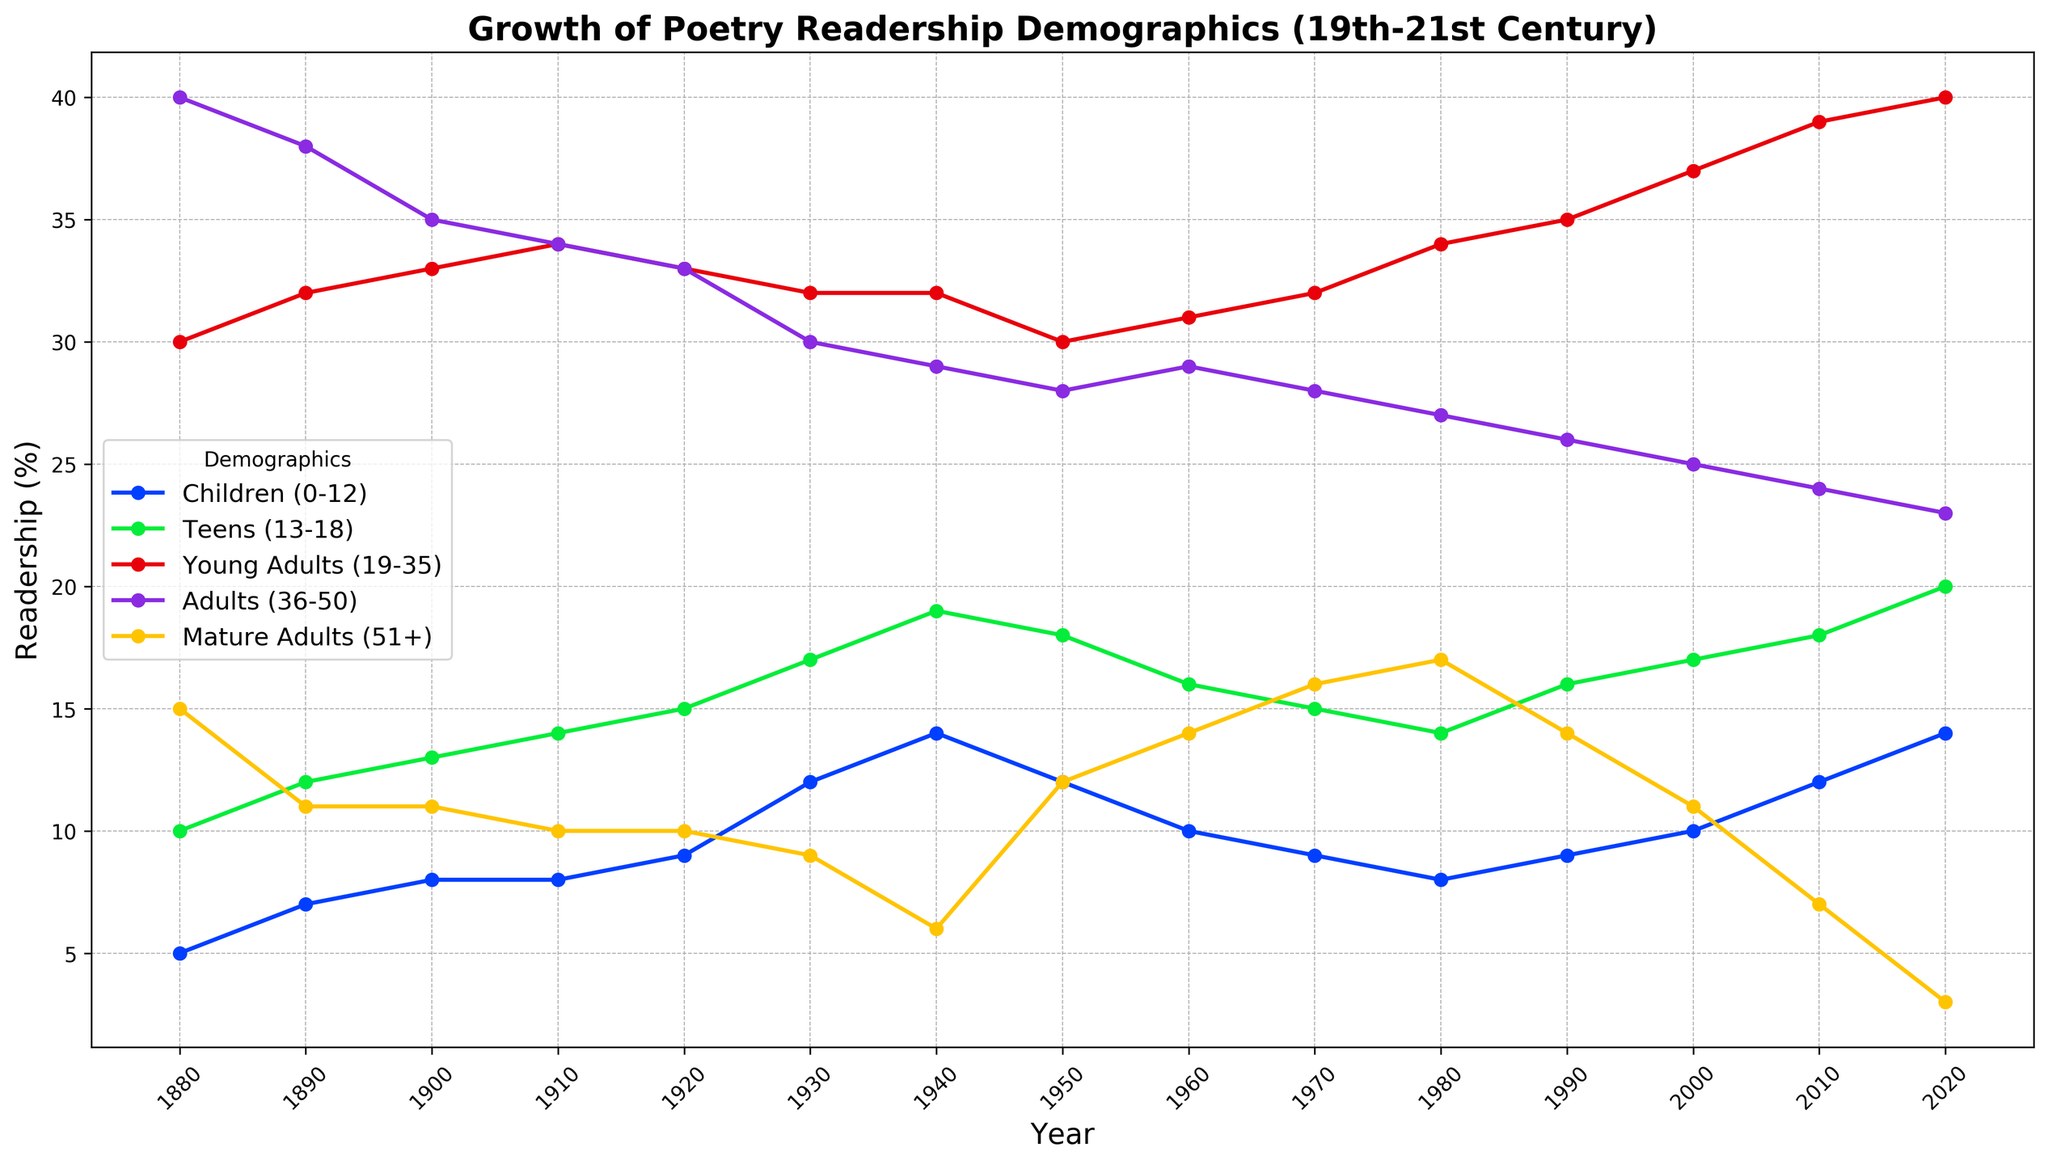What was the percentage of children (0-12) reading poetry in 1920? Look at the ‘Children (0-12)’ line in the chart and find the point corresponding to the year 1920. The value is 9.
Answer: 9 Which demographic had the highest poetry readership in 1980? Check all demographic lines for the year 1980; the highest point belongs to the 'Young Adults (19-35)' line, which is at 34.
Answer: Young Adults (19-35) How does the readership percentage of mature adults (51+) compare between 1880 and 2020? Find the points on the ‘Mature Adults (51+)’ line for 1880 (15) and 2020 (3), then compare.
Answer: Decreased What is the sum of the readership percentages for teens (13-18) and adults (36-50) in 1950? Look at the points on the ‘Teens (13-18)’ line (18) and the ‘Adults (36-50)’ line (28) for 1950. Add these values: 18 + 28 = 46.
Answer: 46 Which demographic showed the least amount of change in poetry readership from 1880 to 2020? Compare the difference from 1880 to 2020 for each demographic. The adult group (36-50) changes from 40 to 23, showing a difference of 17, which is smaller compared to other groups.
Answer: Adults (36-50) In which decade did children (0-12) surpass 10% readership? Identify the first point where the ‘Children (0-12)’ line crosses above 10; this occurs in 1930.
Answer: 1930 What is the difference in readership percentage of young adults (19-35) between 1940 and 2020? Find the points on the ‘Young Adults (19-35)’ line for 1940 (32) and 2020 (40). Calculate the difference: 40 - 32 = 8.
Answer: 8 Between which two consecutive decades did mature adults (51+) experience the largest drop in readership percentage? Look at the drop between consecutive decades on the ‘Mature Adults (51+)’ line; the largest drop is from 1940 (6) to 1950 (12), a difference of 6.
Answer: 1940 to 1950 